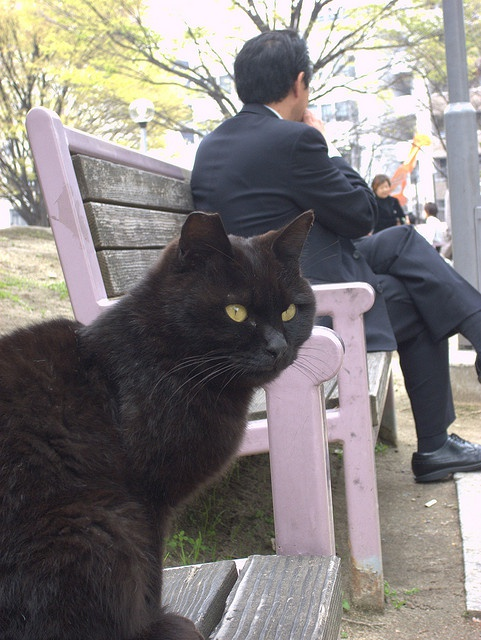Describe the objects in this image and their specific colors. I can see cat in lightyellow, black, and gray tones, bench in lightyellow, darkgray, pink, and lavender tones, people in lightyellow, gray, and black tones, bench in lightyellow, darkgray, lightgray, and gray tones, and people in lightyellow, black, tan, and gray tones in this image. 